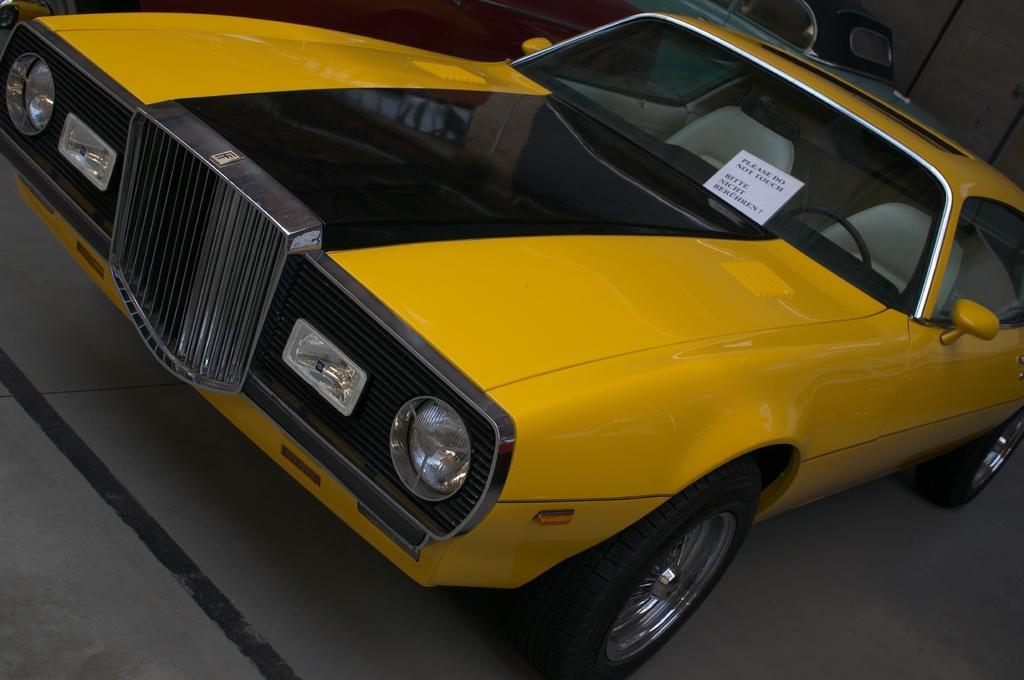Could you give a brief overview of what you see in this image? There is a vehicle in yellow and black color combination on the floor. In the background, there is a vehicle and there is wall. 